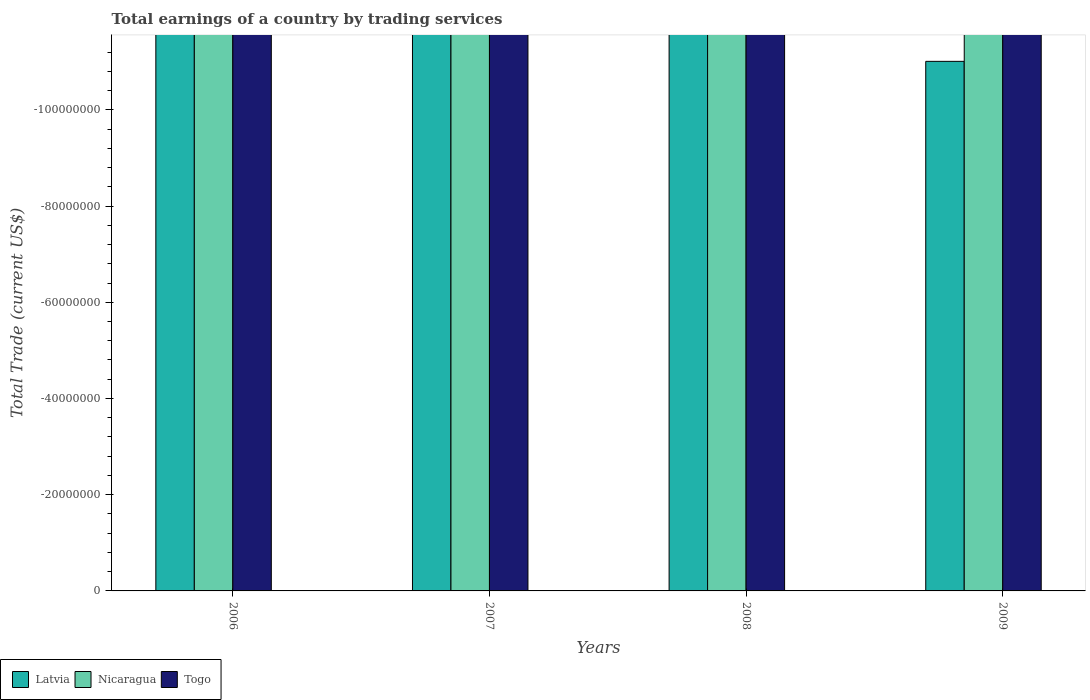How many different coloured bars are there?
Your answer should be very brief. 0. Are the number of bars on each tick of the X-axis equal?
Your answer should be very brief. Yes. How many bars are there on the 2nd tick from the left?
Your answer should be compact. 0. How many bars are there on the 1st tick from the right?
Keep it short and to the point. 0. What is the label of the 1st group of bars from the left?
Make the answer very short. 2006. Across all years, what is the minimum total earnings in Latvia?
Your answer should be compact. 0. What is the total total earnings in Nicaragua in the graph?
Ensure brevity in your answer.  0. In how many years, is the total earnings in Togo greater than -56000000 US$?
Your answer should be compact. 0. In how many years, is the total earnings in Latvia greater than the average total earnings in Latvia taken over all years?
Provide a short and direct response. 0. Is it the case that in every year, the sum of the total earnings in Togo and total earnings in Nicaragua is greater than the total earnings in Latvia?
Make the answer very short. No. How many bars are there?
Offer a very short reply. 0. Are all the bars in the graph horizontal?
Ensure brevity in your answer.  No. Does the graph contain any zero values?
Give a very brief answer. Yes. Where does the legend appear in the graph?
Provide a succinct answer. Bottom left. How many legend labels are there?
Your answer should be compact. 3. How are the legend labels stacked?
Your answer should be very brief. Horizontal. What is the title of the graph?
Offer a terse response. Total earnings of a country by trading services. Does "Low income" appear as one of the legend labels in the graph?
Your answer should be very brief. No. What is the label or title of the Y-axis?
Provide a succinct answer. Total Trade (current US$). What is the Total Trade (current US$) in Latvia in 2006?
Your response must be concise. 0. What is the Total Trade (current US$) in Latvia in 2007?
Offer a terse response. 0. What is the Total Trade (current US$) of Nicaragua in 2008?
Your answer should be compact. 0. What is the Total Trade (current US$) in Togo in 2008?
Offer a terse response. 0. What is the Total Trade (current US$) of Nicaragua in 2009?
Your answer should be compact. 0. What is the total Total Trade (current US$) of Latvia in the graph?
Provide a succinct answer. 0. What is the total Total Trade (current US$) of Nicaragua in the graph?
Give a very brief answer. 0. 